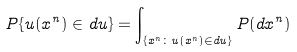<formula> <loc_0><loc_0><loc_500><loc_500>P \{ u ( x ^ { n } ) \in d u \} = \int _ { \{ x ^ { n } \colon u ( x ^ { n } ) \in d u \} } P ( d x ^ { n } )</formula> 